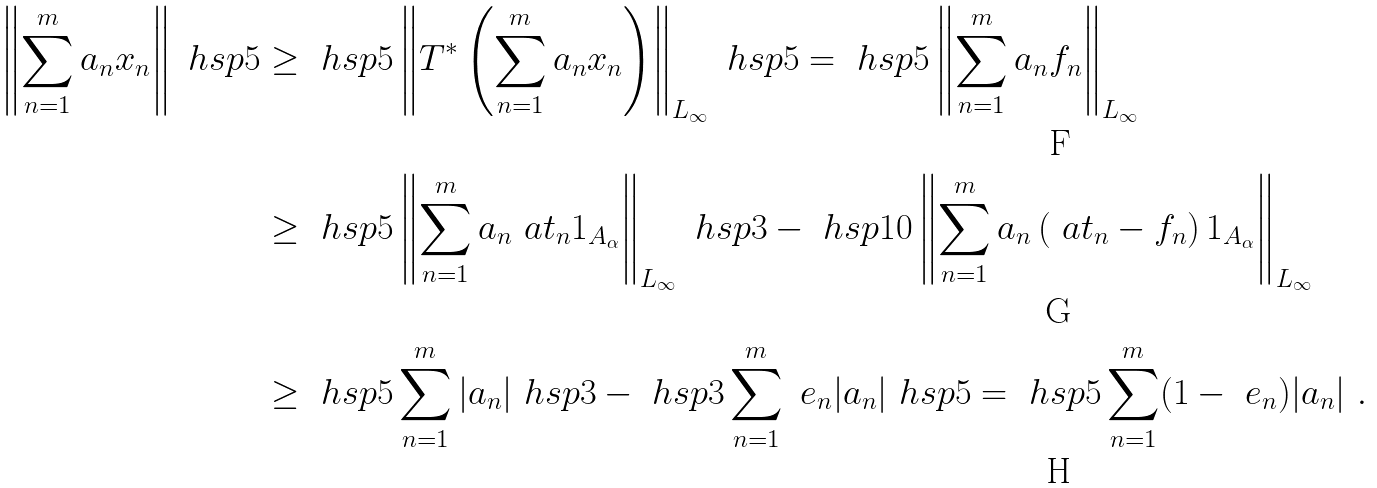<formula> <loc_0><loc_0><loc_500><loc_500>\left \| \sum _ { n = 1 } ^ { m } a _ { n } x _ { n } \right \| \ h s p { 5 } & \geq \ h s p { 5 } \left \| T ^ { * } \left ( \sum _ { n = 1 } ^ { m } a _ { n } x _ { n } \right ) \right \| _ { L _ { \infty } } \ h s p { 5 } = \ h s p { 5 } \left \| \sum _ { n = 1 } ^ { m } a _ { n } f _ { n } \right \| _ { L _ { \infty } } \\ & \geq \ h s p { 5 } \left \| \sum _ { n = 1 } ^ { m } a _ { n } \ a t _ { n } 1 _ { A _ { \alpha } } \right \| _ { L _ { \infty } } \ h s p { 3 } - \ h s p { 1 0 } \left \| \sum _ { n = 1 } ^ { m } a _ { n } \left ( \ a t _ { n } - f _ { n } \right ) 1 _ { A _ { \alpha } } \right \| _ { L _ { \infty } } \\ & \geq \ h s p { 5 } \sum _ { n = 1 } ^ { m } | a _ { n } | \ h s p { 3 } - \ h s p { 3 } \sum _ { n = 1 } ^ { m } \ e _ { n } | a _ { n } | \ h s p { 5 } = \ h s p { 5 } \sum _ { n = 1 } ^ { m } ( 1 - \ e _ { n } ) | a _ { n } | \ .</formula> 